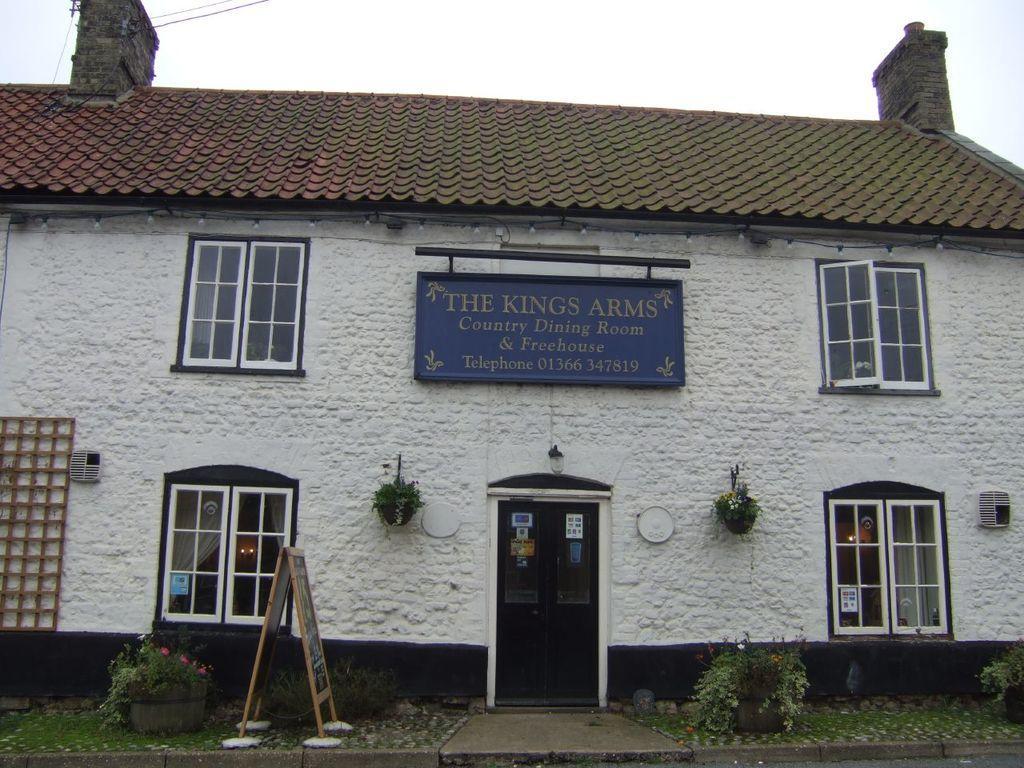In one or two sentences, can you explain what this image depicts? In this image there is a building, in front of the building there is a board, plant pots and there is an object on the left side of the image and there is a board with some text and two plant pots are hanging on the wall of a building, in the background there is the sky. 